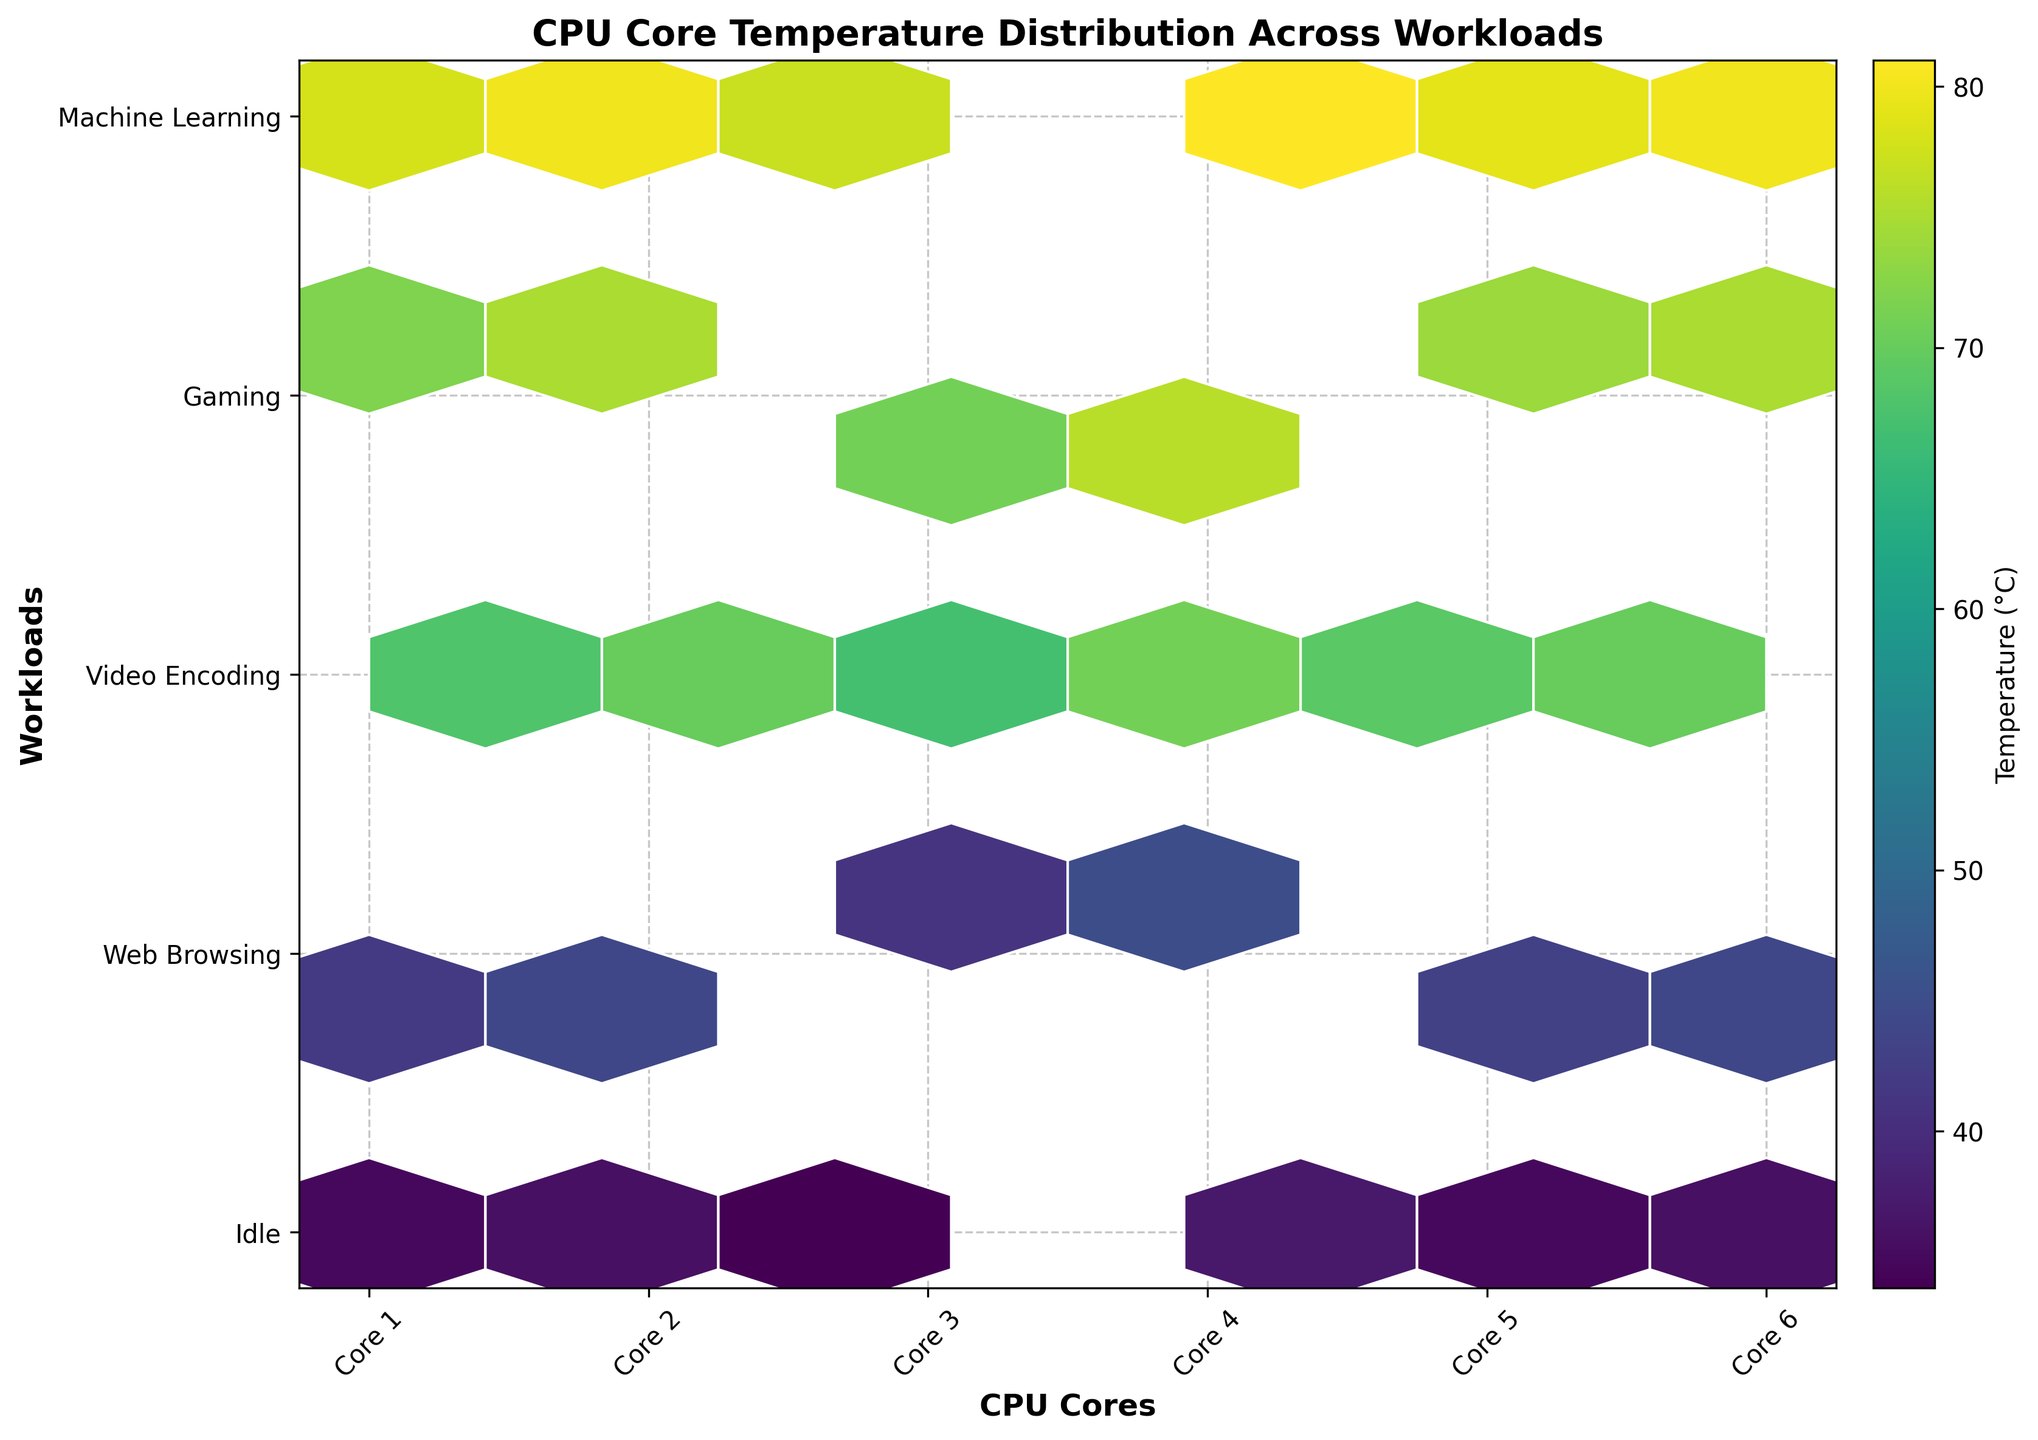What is the title of the plot? The title of the plot is located at the top of the figure.
Answer: CPU Core Temperature Distribution Across Workloads Which core experiences the highest temperature during Machine Learning workloads? Find the "Machine Learning" row on the y-axis, then look for the hexagon with the highest color intensity in that row. Cross-reference the x-axis for the corresponding core.
Answer: Core 4 How many workload types are displayed in the figure? The y-axis lists all the workloads. Count the number of unique labels.
Answer: 5 Which workload has the lowest temperature across all cores? Look at the hexbin plots with the lowest color intensity and cross-reference with the y-axis labels to find the workload.
Answer: Idle On average, which workloads result in higher temperatures: Video Encoding or Web Browsing? Compare the average color intensity (more yellowish) of the hexagons in the "Video Encoding" row to those in the "Web Browsing" row.
Answer: Video Encoding Which core shows the most uniform temperature distribution across different workloads? Identify the core with hexagons of similar color intensity across its entire column.
Answer: Core 3 What is the color indicator used to represent temperature in the hexbin plot? Refer to the color legend or color gradient bar to determine the representation.
Answer: viridis Which workload causes the highest average temperature increase from the 'Idle' state across all cores? For each core, calculate the temperature difference between the 'Idle' state and each workload. Average these differences across all cores and identify the workload with the highest average increase.
Answer: Machine Learning What does the color bar represent, and what is its unit? The color bar typically found at the side of the plot indicates what and in what unit the information is represented.
Answer: Temperature (°C) Are there any instances where cores report the same temperature for different workloads? Look for hexagons that overlap in position across different rows, indicating the same temperature.
Answer: No 